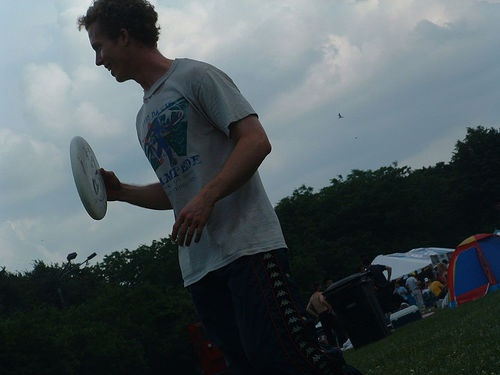Describe the objects in this image and their specific colors. I can see people in lightblue, black, purple, and darkblue tones, frisbee in lightblue, purple, and black tones, people in lightblue, black, gray, and darkblue tones, people in lightblue, black, darkblue, and gray tones, and people in lightblue, black, maroon, olive, and gray tones in this image. 